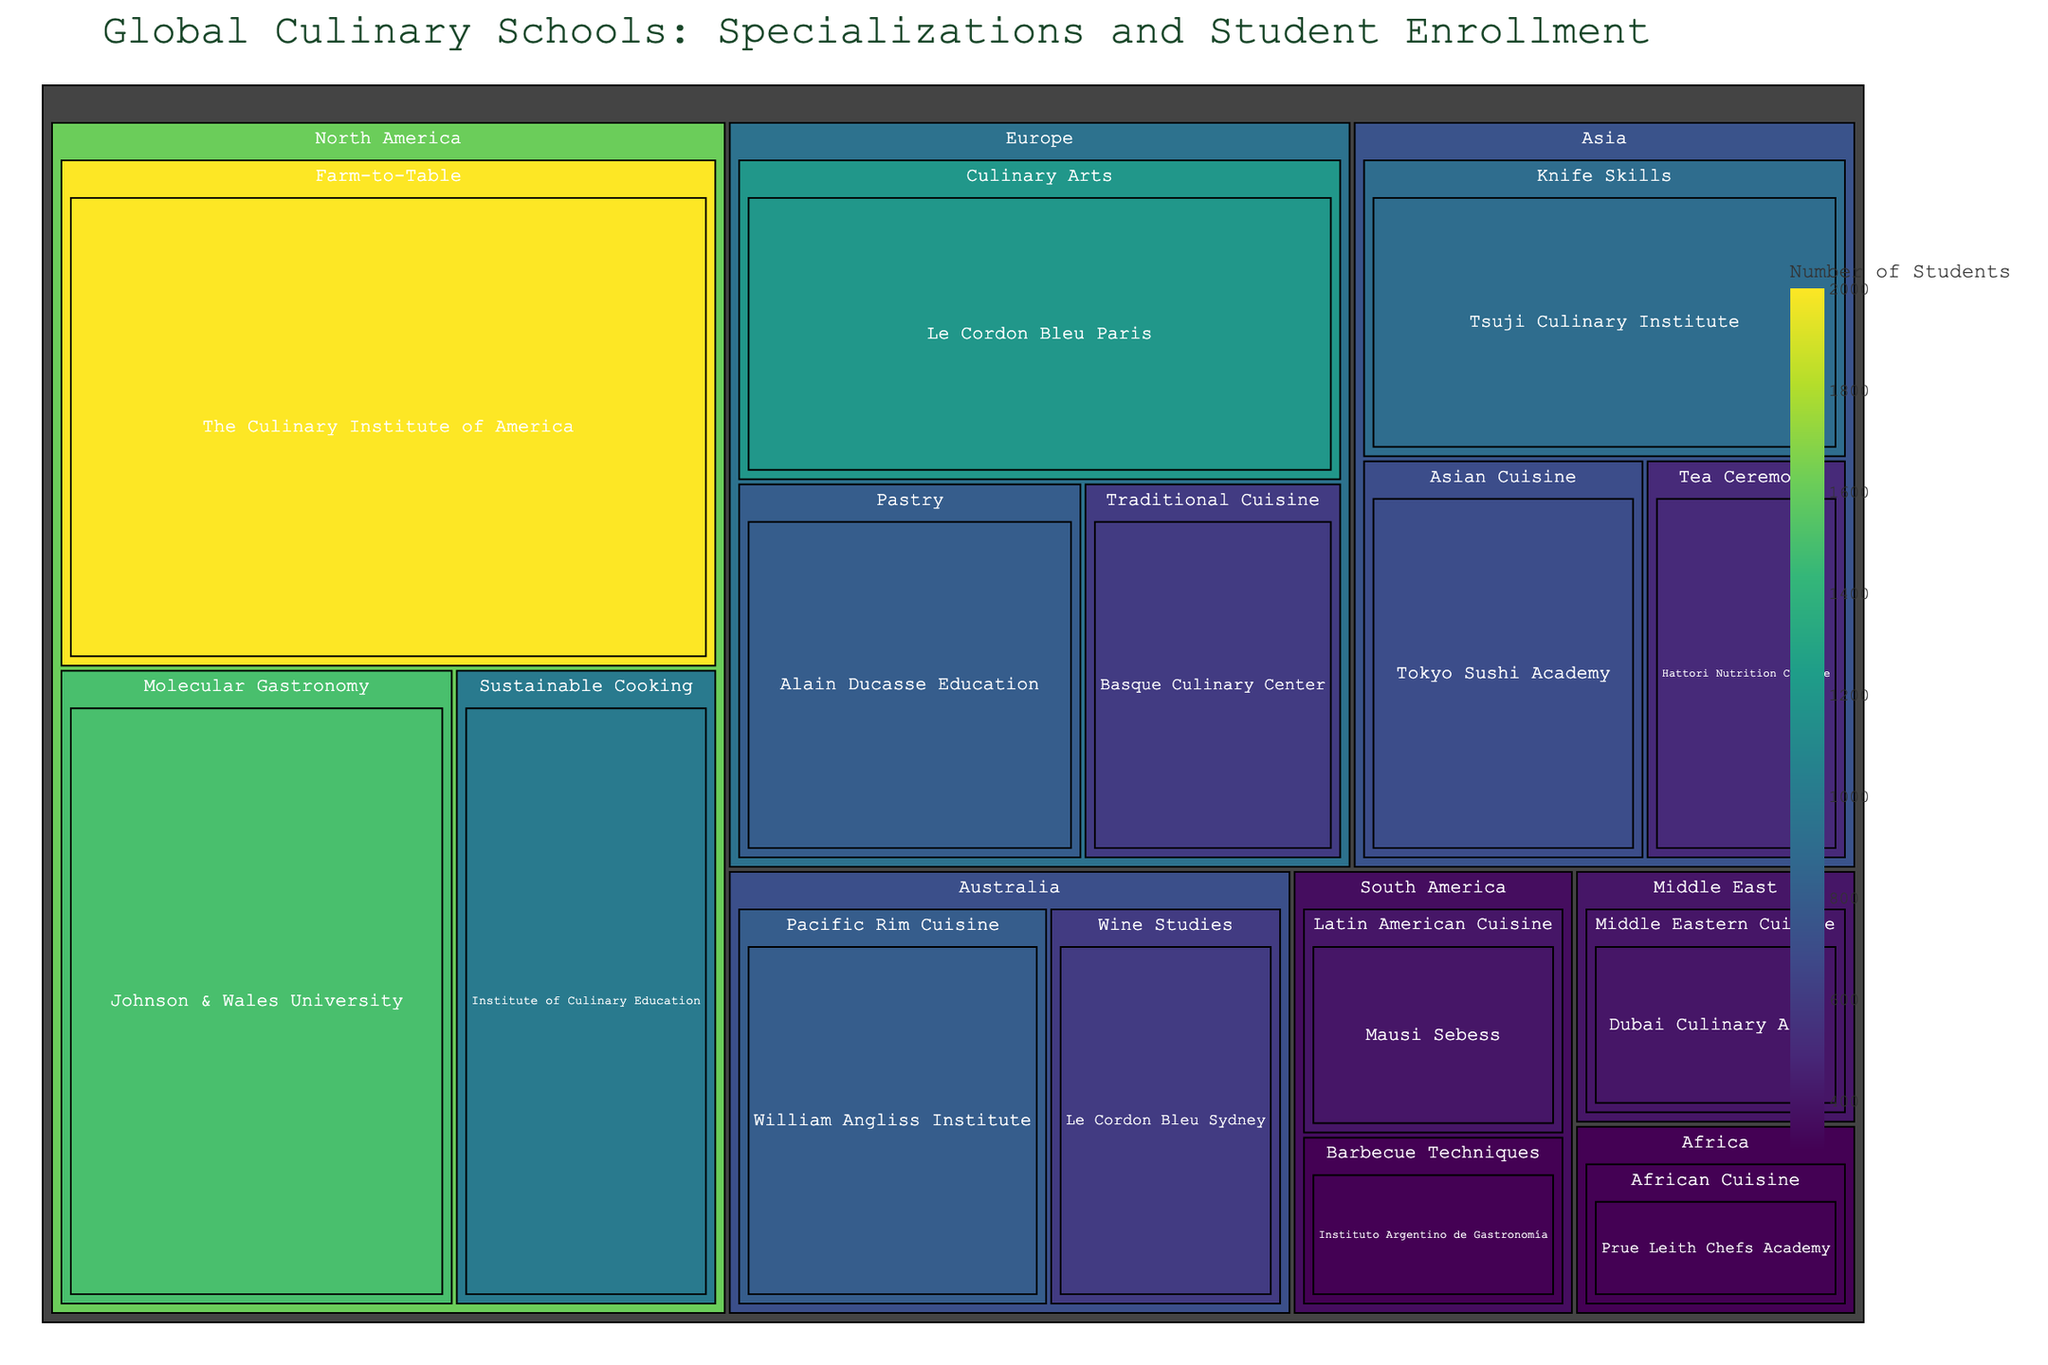Which region has the highest number of students enrolled in culinary schools? To determine the region with the highest student enrollment, we compare the size of the regions in the treemap. North America has the largest section.
Answer: North America What is the total number of students enrolled in culinary schools in Europe? We sum the number of students in each European culinary school. Le Cordon Bleu Paris has 1200 students, Alain Ducasse Education has 800 students, and Basque Culinary Center has 600 students. Therefore, the total is 1200 + 800 + 600 = 2600.
Answer: 2600 Which culinary school specializes in Molecular Gastronomy, and how many students are enrolled there? We locate the specialization "Molecular Gastronomy" in the treemap, which shows Johnson & Wales University. The student enrollment for this school is 1500.
Answer: Johnson & Wales University, 1500 Compare the student enrollment in "Farm-to-Table" specialization between North America and Asia. By examining the treemap, only North America has a "Farm-to-Table" specialization, with The Culinary Institute of America having 2000 students. Asia does not have this specialization. Therefore, the comparison is North America 2000 vs. Asia 0.
Answer: North America 2000, Asia 0 What is the average number of students enrolled in culinary schools in South America? First, we find the student numbers for each school in South America: Mausi Sebess with 400 students and Instituto Argentino de Gastronomía with 300 students. The average is calculated as (400 + 300) / 2 = 350.
Answer: 350 Which school has the highest number of students enrolled in Asia, and what is the specialization? We identify the schools in Asia from the treemap: Tokyo Sushi Academy (700), Tsuji Culinary Institute (900), and Hattori Nutrition College (500). Tsuji Culinary Institute has the highest enrollment with 900 students, specializing in Knife Skills.
Answer: Tsuji Culinary Institute, Knife Skills, 900 What is the most common specialization across all regions based on the number of schools? By examining the treemap, we see the number of schools per specialization. Each specialization generally has one school associated, so no clear dominant specialization is depicted. Therefore, there's no specialization that appears more frequently than others.
Answer: No dominant specialization Compare the number of students in the African Cuisine specialization to the Latin American Cuisine specialization. African Cuisine is represented by Prue Leith Chefs Academy with 300 students, while Latin American Cuisine is represented by Mausi Sebess with 400 students.
Answer: African Cuisine 300, Latin American Cuisine 400 Is there any region where the total number of students is less than 1000? If so, which region? By comparing the total number of students in each region on the treemap, Africa (Prue Leith Chefs Academy, 300 students) and South America (400 + 300 = 700 students) both have less than 1000 students each.
Answer: Africa, South America 